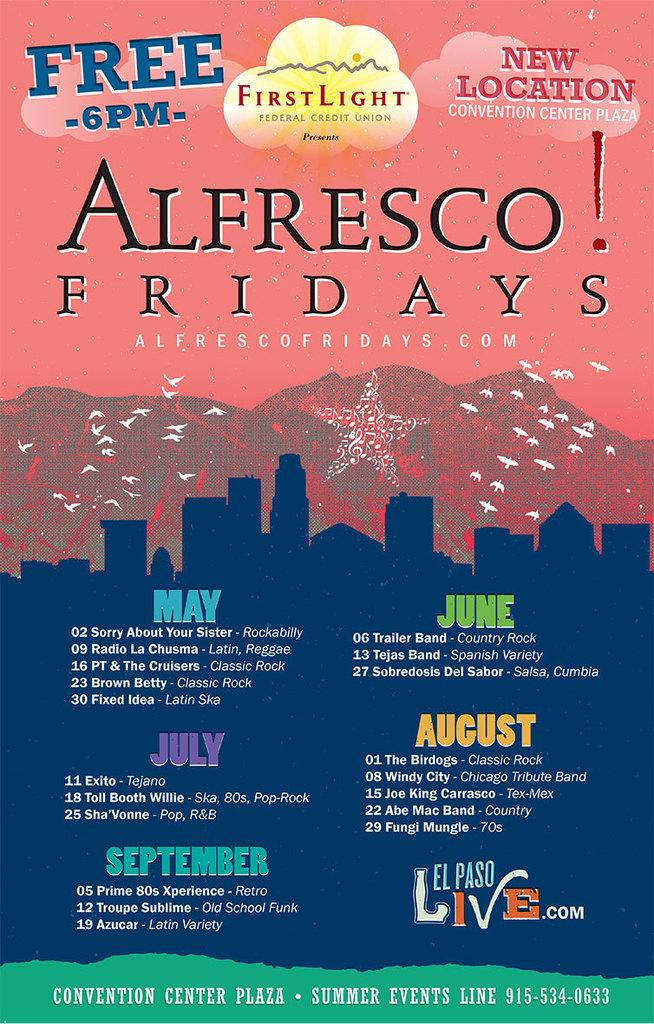What time does the event start?
Your response must be concise. 6pm. What is the name of the event?
Offer a terse response. Alfresco fridays. 